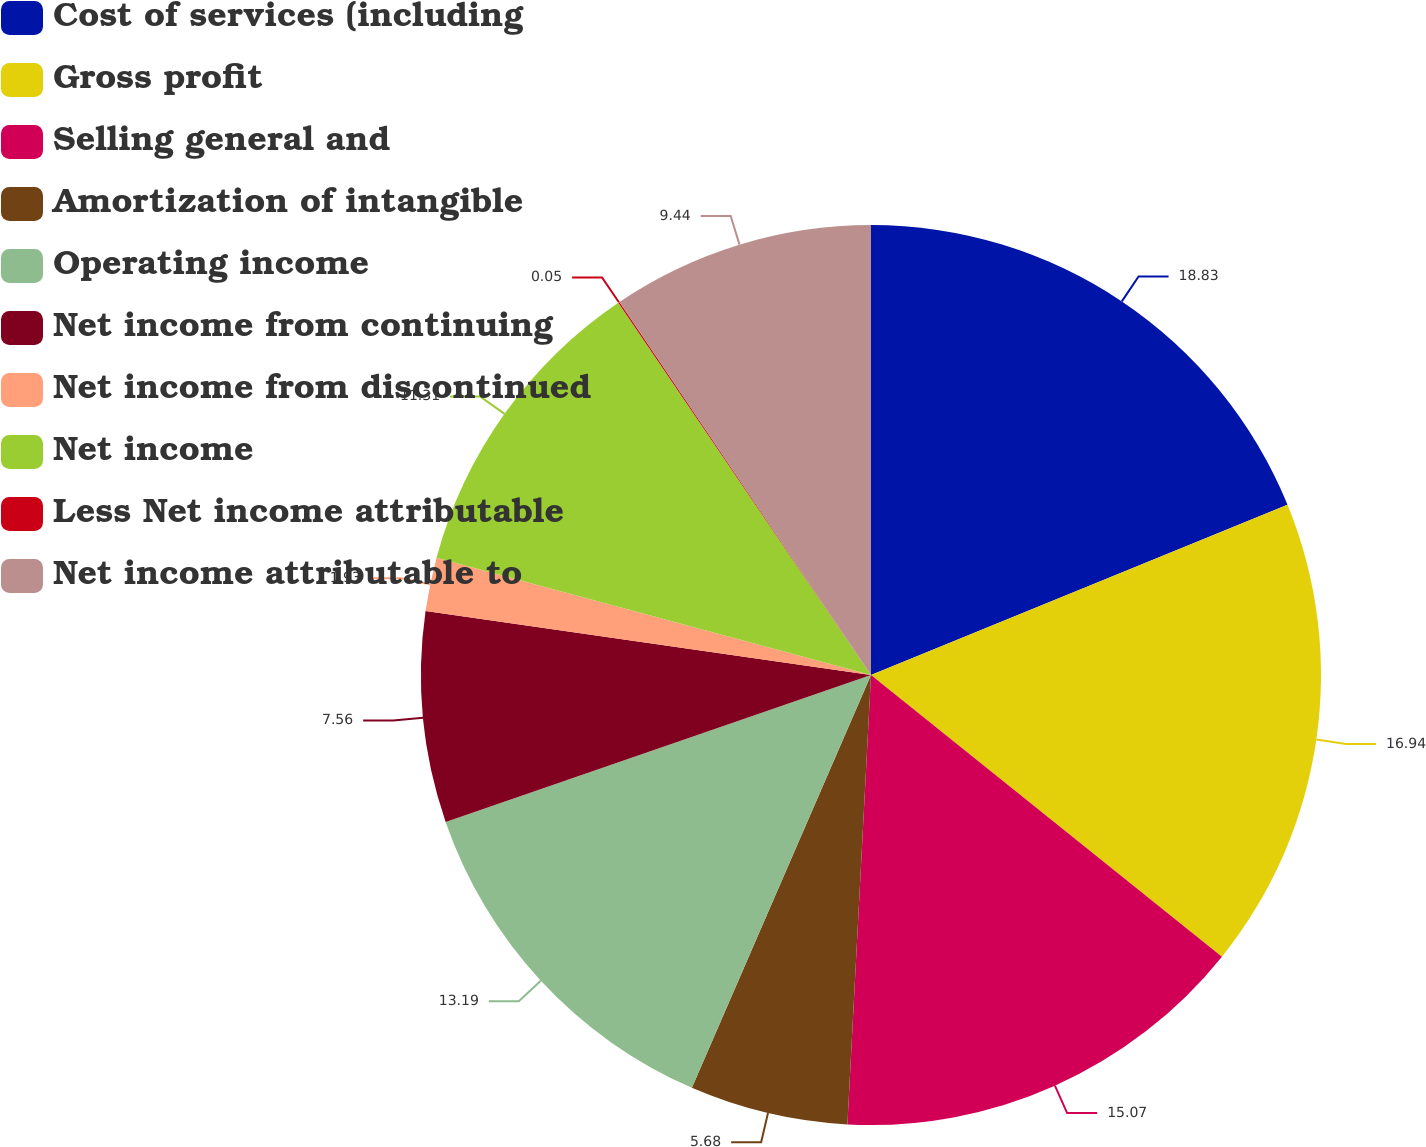<chart> <loc_0><loc_0><loc_500><loc_500><pie_chart><fcel>Cost of services (including<fcel>Gross profit<fcel>Selling general and<fcel>Amortization of intangible<fcel>Operating income<fcel>Net income from continuing<fcel>Net income from discontinued<fcel>Net income<fcel>Less Net income attributable<fcel>Net income attributable to<nl><fcel>18.82%<fcel>16.94%<fcel>15.07%<fcel>5.68%<fcel>13.19%<fcel>7.56%<fcel>1.93%<fcel>11.31%<fcel>0.05%<fcel>9.44%<nl></chart> 